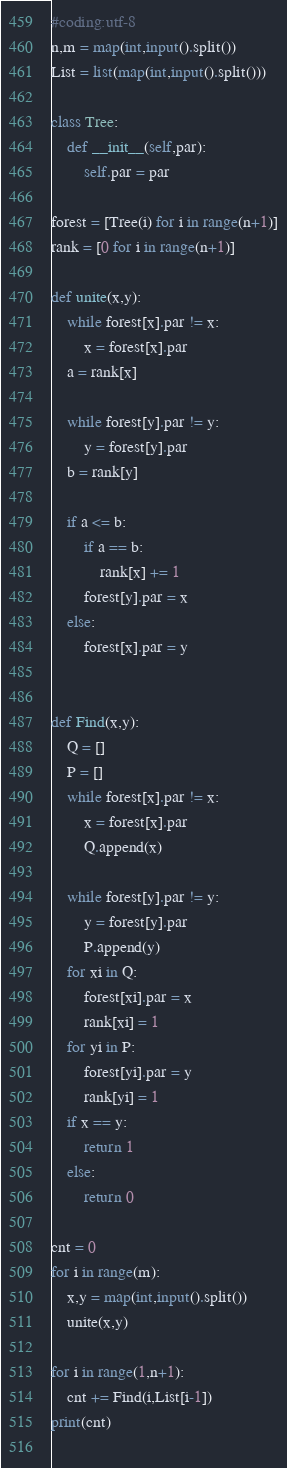<code> <loc_0><loc_0><loc_500><loc_500><_Python_>#coding:utf-8
n,m = map(int,input().split())
List = list(map(int,input().split()))

class Tree:
    def __init__(self,par):
        self.par = par

forest = [Tree(i) for i in range(n+1)]
rank = [0 for i in range(n+1)]

def unite(x,y):
    while forest[x].par != x:
        x = forest[x].par
    a = rank[x]
    
    while forest[y].par != y:
        y = forest[y].par
    b = rank[y]
    
    if a <= b:
        if a == b:
            rank[x] += 1
        forest[y].par = x
    else:
        forest[x].par = y


def Find(x,y):
    Q = []
    P = []
    while forest[x].par != x:
        x = forest[x].par
        Q.append(x)
            
    while forest[y].par != y:
        y = forest[y].par
        P.append(y)
    for xi in Q:
        forest[xi].par = x
        rank[xi] = 1
    for yi in P:
        forest[yi].par = y
        rank[yi] = 1
    if x == y:
        return 1
    else:
        return 0
    
cnt = 0
for i in range(m):
    x,y = map(int,input().split())
    unite(x,y)

for i in range(1,n+1):
    cnt += Find(i,List[i-1])
print(cnt)
    
</code> 